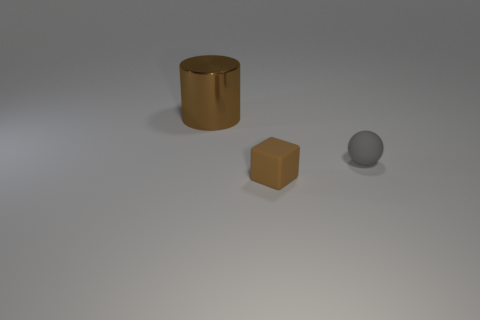Add 1 small brown rubber objects. How many objects exist? 4 Subtract 1 cylinders. How many cylinders are left? 0 Subtract 1 brown cylinders. How many objects are left? 2 Subtract all brown spheres. How many purple cylinders are left? 0 Subtract all tiny gray matte objects. Subtract all rubber cubes. How many objects are left? 1 Add 3 large metal things. How many large metal things are left? 4 Add 3 gray matte objects. How many gray matte objects exist? 4 